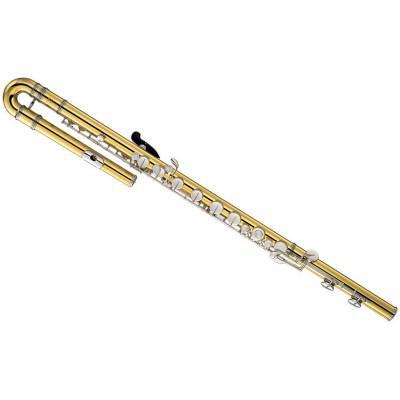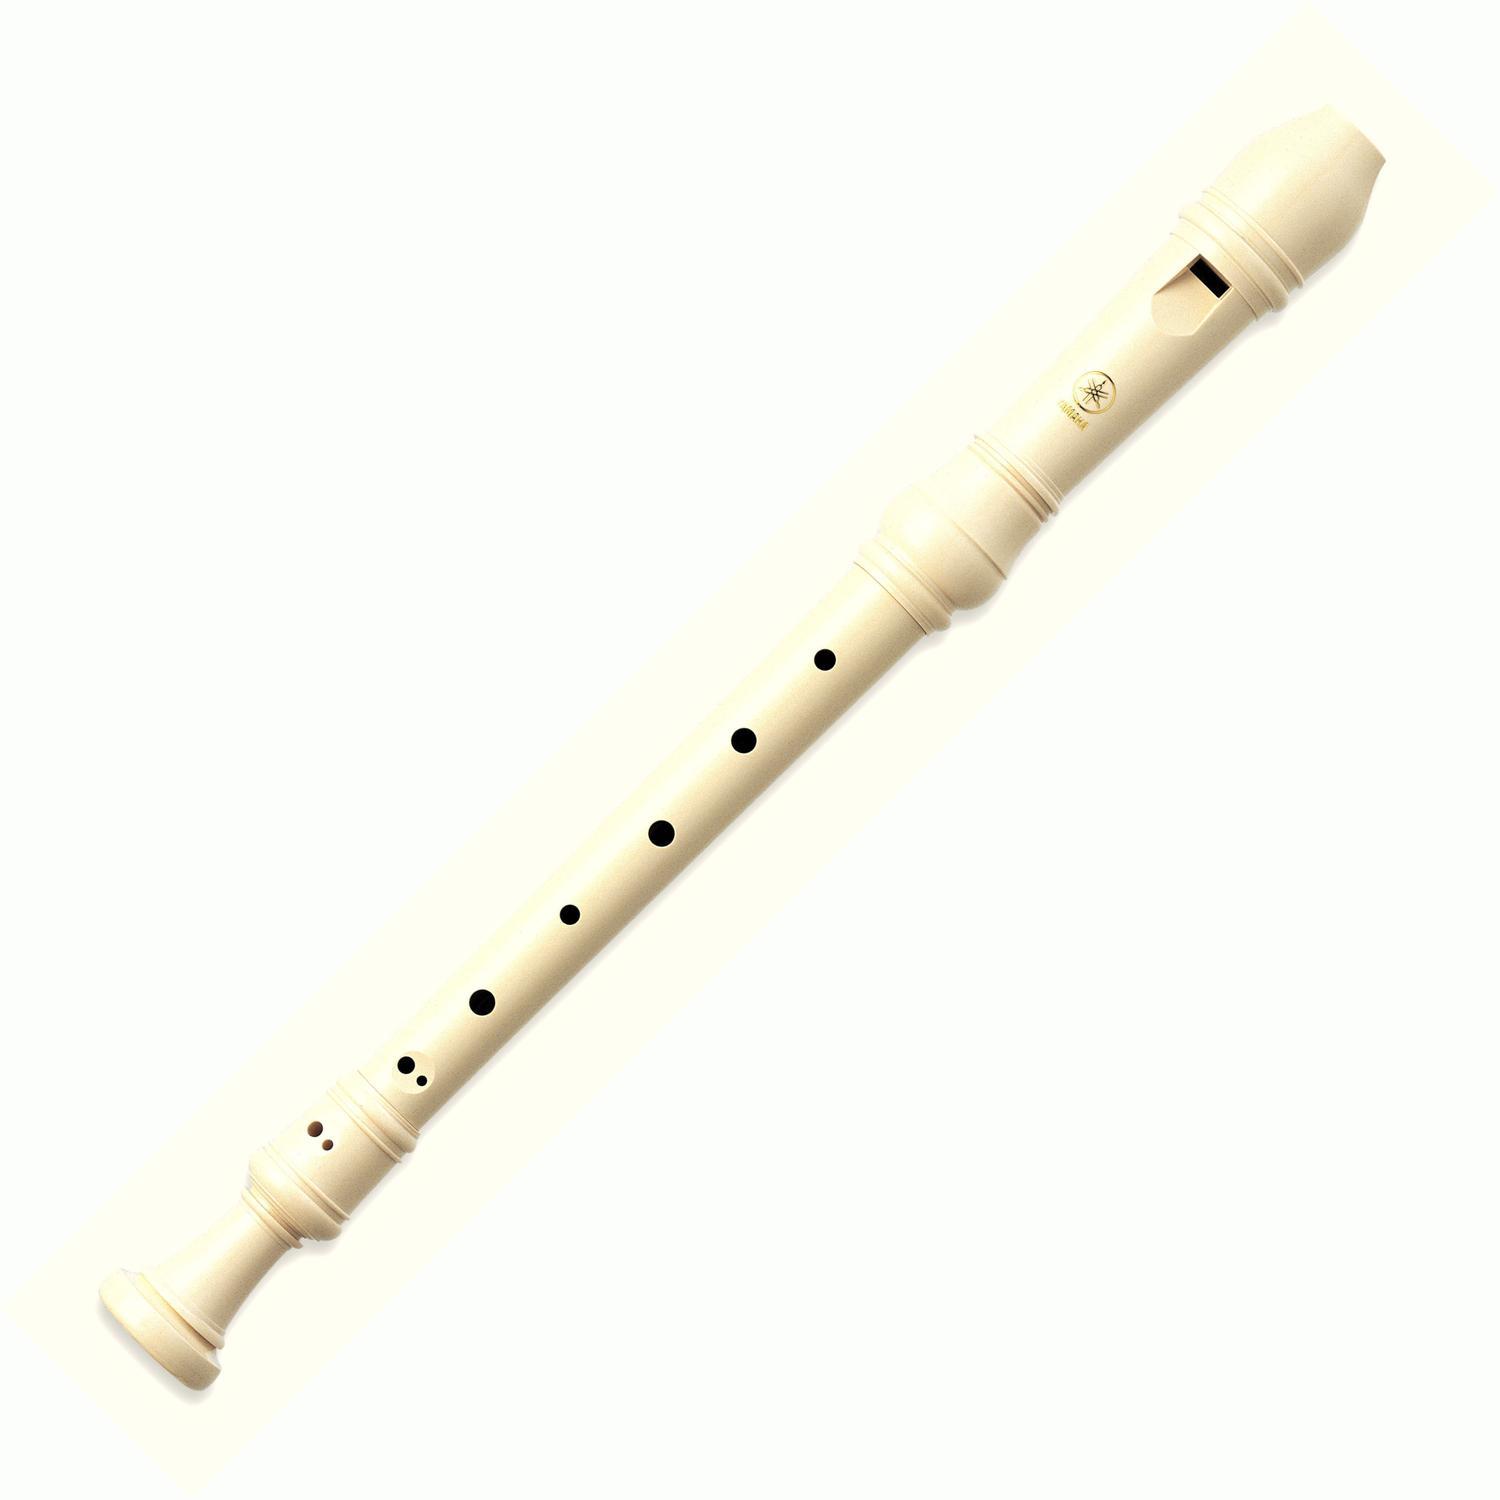The first image is the image on the left, the second image is the image on the right. Given the left and right images, does the statement "The left and right image contains the same number of hooked flutes." hold true? Answer yes or no. No. The first image is the image on the left, the second image is the image on the right. For the images displayed, is the sentence "There are two curved head flutes." factually correct? Answer yes or no. No. 